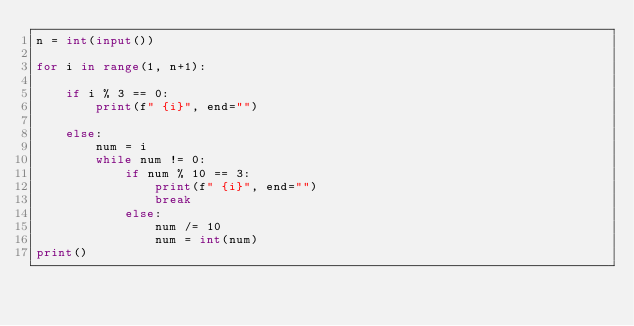Convert code to text. <code><loc_0><loc_0><loc_500><loc_500><_Python_>n = int(input())

for i in range(1, n+1):

    if i % 3 == 0:
        print(f" {i}", end="")

    else:
        num = i
        while num != 0:
            if num % 10 == 3:
                print(f" {i}", end="")
                break
            else:
                num /= 10
                num = int(num)
print()

</code> 